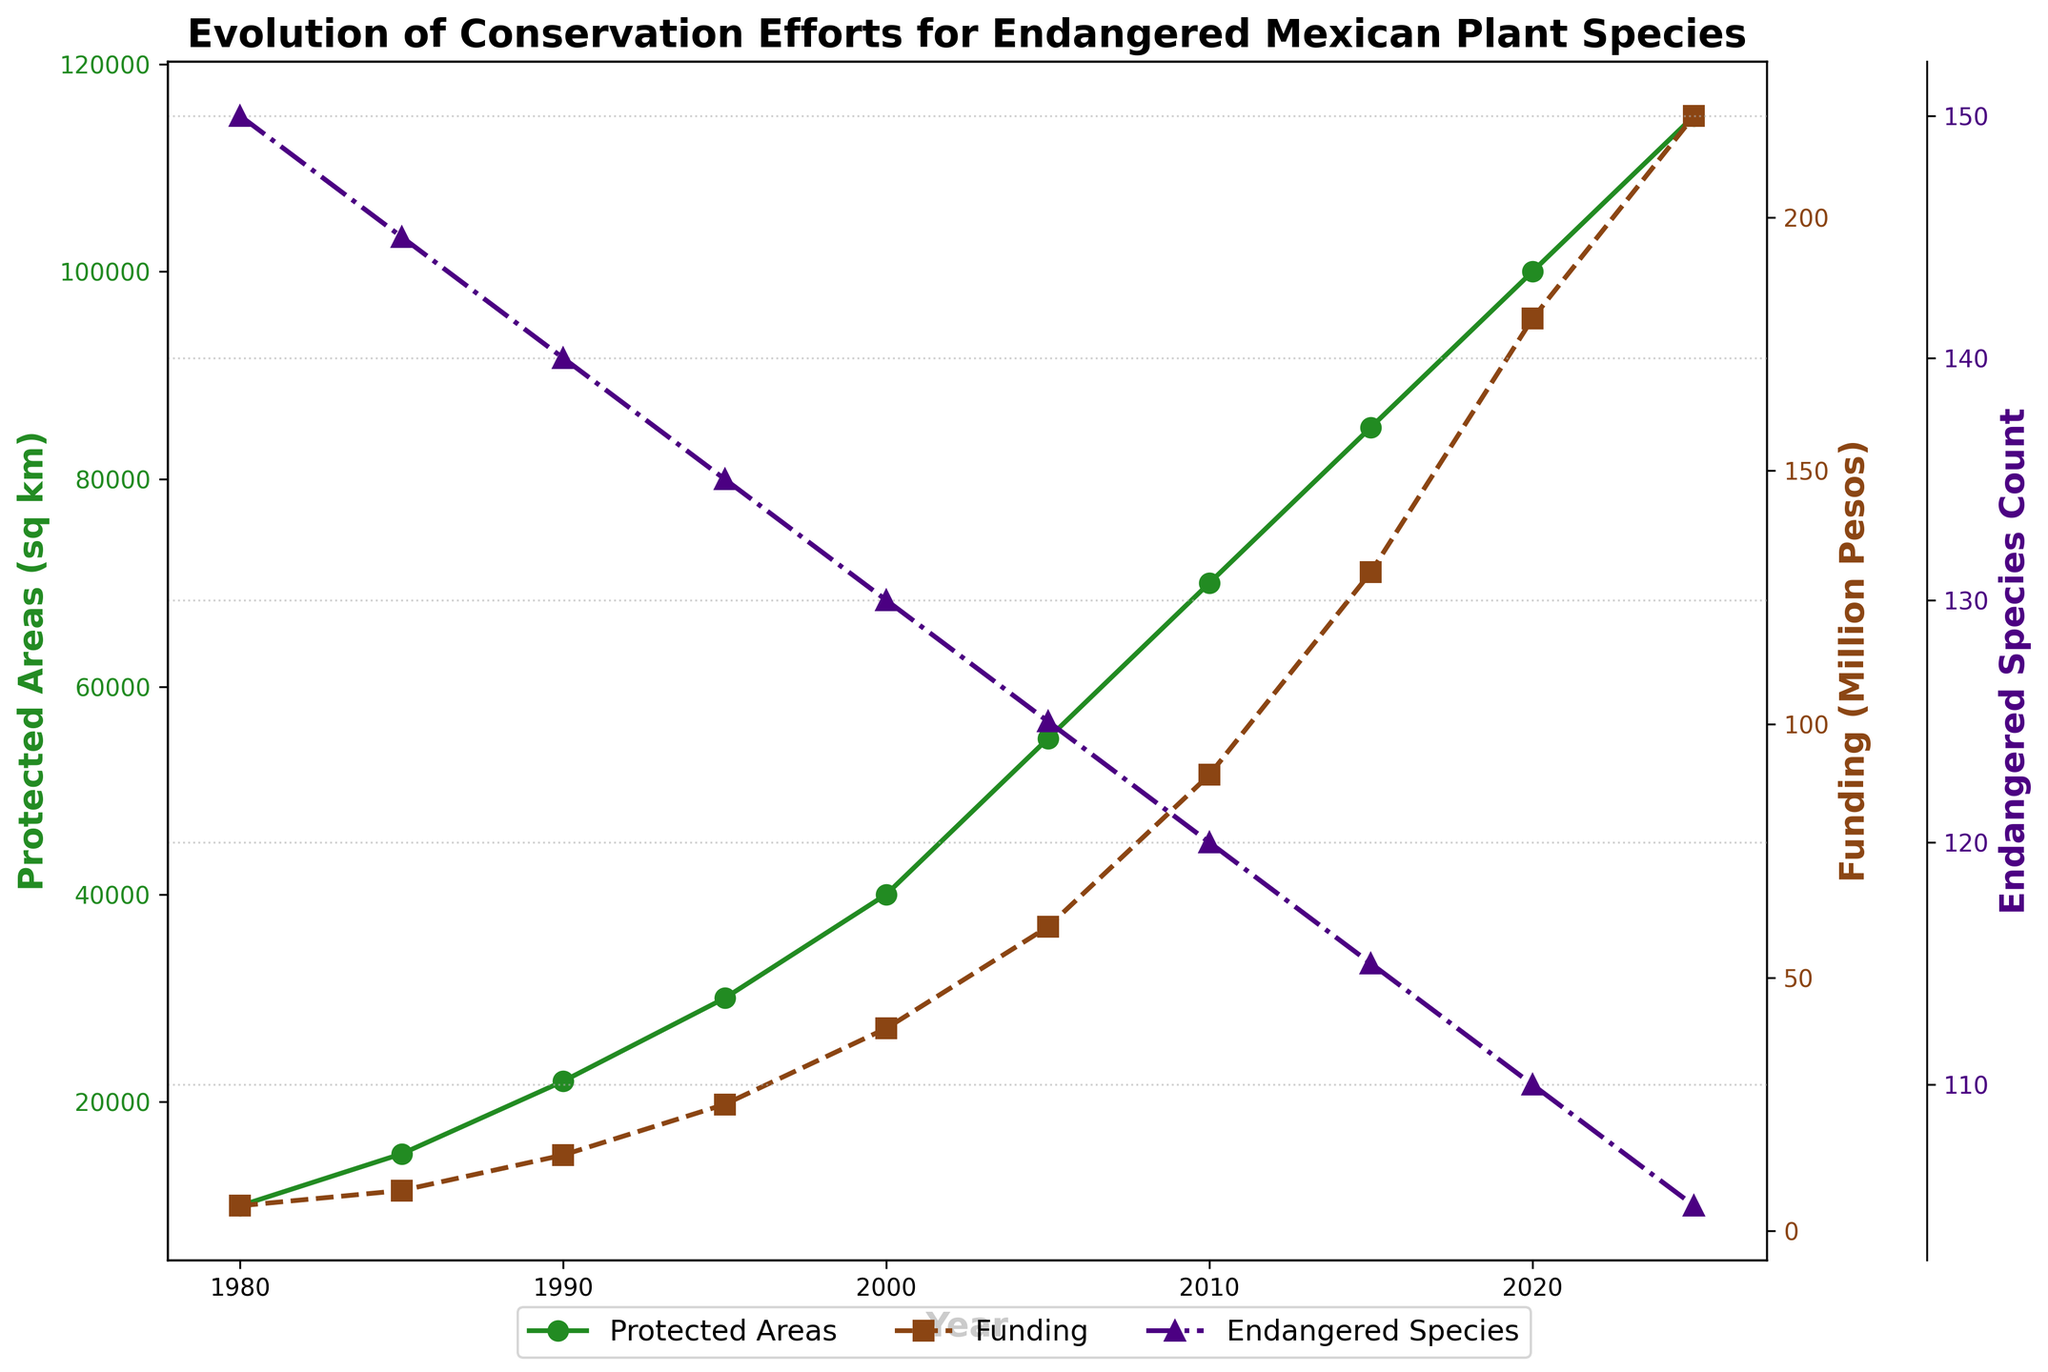What's the trend of the protected areas over the years? Starting from 1980, there is a continual increase in the protected areas until 2025.
Answer: Continual increase What is the difference in funding between 2000 and 2020? The funding in 2020 is 180 Million Pesos and in 2000 it is 40 Million Pesos. The difference is 180 - 40 = 140 Million Pesos.
Answer: 140 Million Pesos How does the count of endangered species change from 1980 to 2025? The count of endangered species decreases from 150 in 1980 to 105 in 2025.
Answer: Decreases Which year shows the largest increase in protected areas compared to the previous record? From 2000 to 2005, the increase in protected areas is largest, which is 55000 - 40000 = 15000 sq km.
Answer: 2000 to 2005 What color represents the endangered species count on the plot? The endangered species count is represented by the color purple (indigo).
Answer: Purple (Indigo) How much did the protected areas increase from 2015 to 2025? The increase from 2015 (85000 sq km) to 2025 (115000 sq km) is 115000 - 85000 = 30000 sq km.
Answer: 30000 sq km Compare the funding allocations in 1995 and 2025. Which year had a higher allocation? In 2025, the funding allocation is 220 Million Pesos, while in 1995 it is 25 Million Pesos. Hence, 2025 had a higher allocation.
Answer: 2025 Is there any correlation between the increase in protected areas and the funding allocation over the years? Both protected areas and funding allocation show a consistent increasing trend over the years, indicating a positive correlation.
Answer: Positive correlation What is the visual observation regarding the trend of endangered species count? The endangered species count consistently decreases from 1980 to 2025.
Answer: Consistently decreases 